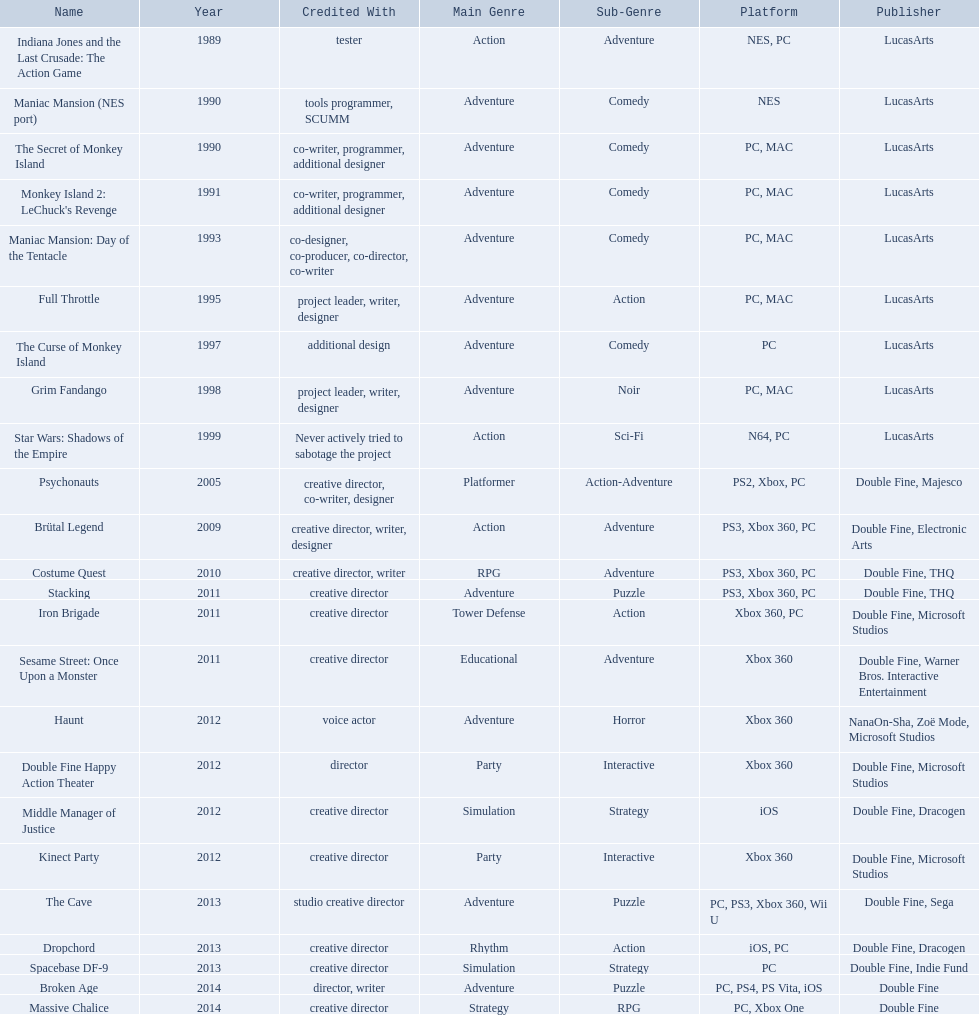Which game is credited with a creative director? Creative director, co-writer, designer, creative director, writer, designer, creative director, writer, creative director, creative director, creative director, creative director, creative director, creative director, creative director, creative director. Of these games, which also has warner bros. interactive listed as creative director? Sesame Street: Once Upon a Monster. 